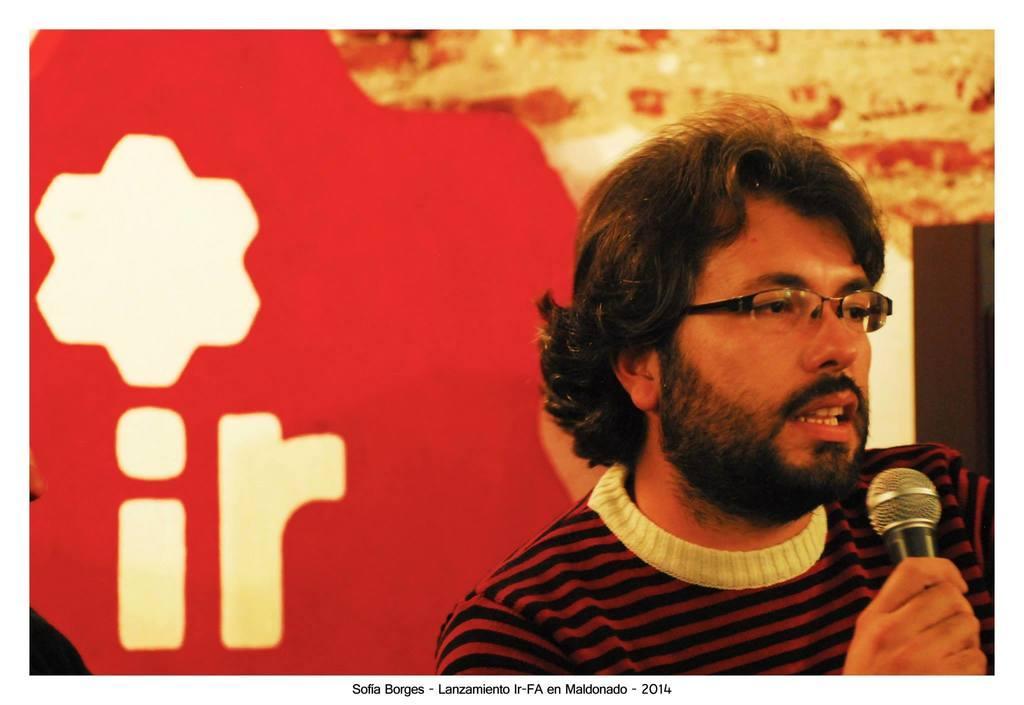How would you summarize this image in a sentence or two? The man in front of the picture wearing maroon and black T-shirt is holding a microphone in his hand. He is talking on the microphone. He is wearing the spectacles. Behind him, we see a red color board. On the right side, we see a wall or a cupboard in white and brown color. 